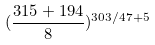Convert formula to latex. <formula><loc_0><loc_0><loc_500><loc_500>( \frac { 3 1 5 + 1 9 4 } { 8 } ) ^ { 3 0 3 / 4 7 + 5 }</formula> 